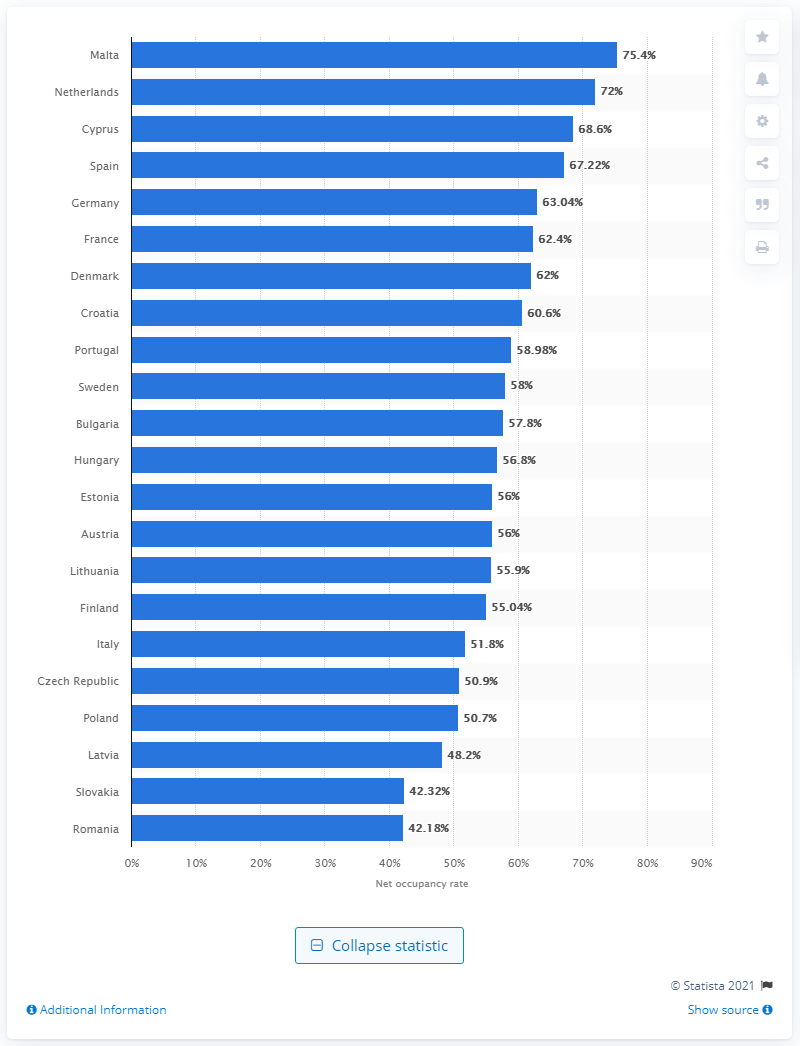Outline some significant characteristics in this image. The net occupancy rate of bedrooms in hotels in Malta in 2019 was 75.4%. 